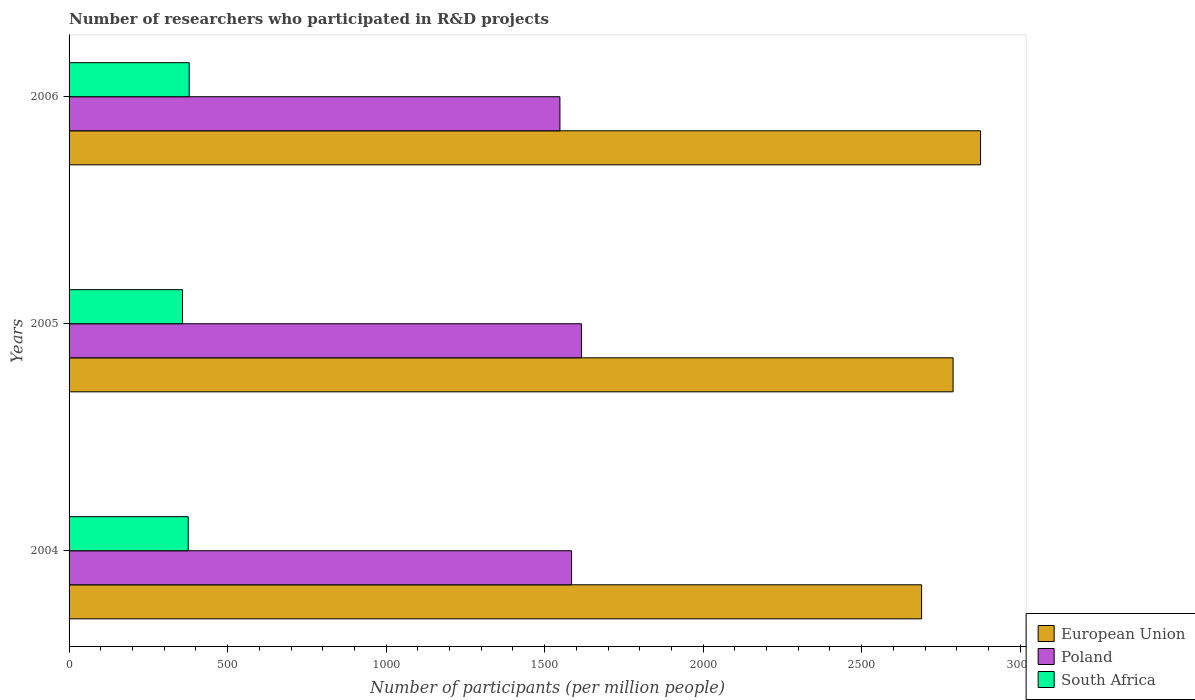How many different coloured bars are there?
Offer a terse response. 3. How many groups of bars are there?
Provide a short and direct response. 3. Are the number of bars on each tick of the Y-axis equal?
Make the answer very short. Yes. In how many cases, is the number of bars for a given year not equal to the number of legend labels?
Make the answer very short. 0. What is the number of researchers who participated in R&D projects in European Union in 2006?
Give a very brief answer. 2874.94. Across all years, what is the maximum number of researchers who participated in R&D projects in South Africa?
Your answer should be compact. 378.82. Across all years, what is the minimum number of researchers who participated in R&D projects in Poland?
Keep it short and to the point. 1548.2. What is the total number of researchers who participated in R&D projects in South Africa in the graph?
Offer a terse response. 1112.49. What is the difference between the number of researchers who participated in R&D projects in Poland in 2004 and that in 2005?
Your answer should be very brief. -31.3. What is the difference between the number of researchers who participated in R&D projects in European Union in 2006 and the number of researchers who participated in R&D projects in South Africa in 2005?
Make the answer very short. 2517.09. What is the average number of researchers who participated in R&D projects in South Africa per year?
Provide a short and direct response. 370.83. In the year 2005, what is the difference between the number of researchers who participated in R&D projects in European Union and number of researchers who participated in R&D projects in South Africa?
Provide a short and direct response. 2430.43. In how many years, is the number of researchers who participated in R&D projects in Poland greater than 1900 ?
Ensure brevity in your answer.  0. What is the ratio of the number of researchers who participated in R&D projects in Poland in 2005 to that in 2006?
Your answer should be compact. 1.04. Is the difference between the number of researchers who participated in R&D projects in European Union in 2005 and 2006 greater than the difference between the number of researchers who participated in R&D projects in South Africa in 2005 and 2006?
Ensure brevity in your answer.  No. What is the difference between the highest and the second highest number of researchers who participated in R&D projects in South Africa?
Your answer should be compact. 3. What is the difference between the highest and the lowest number of researchers who participated in R&D projects in Poland?
Provide a succinct answer. 67.94. What does the 3rd bar from the top in 2005 represents?
Keep it short and to the point. European Union. What does the 2nd bar from the bottom in 2005 represents?
Your response must be concise. Poland. How many bars are there?
Provide a short and direct response. 9. How many years are there in the graph?
Offer a very short reply. 3. Are the values on the major ticks of X-axis written in scientific E-notation?
Ensure brevity in your answer.  No. Where does the legend appear in the graph?
Provide a short and direct response. Bottom right. How are the legend labels stacked?
Provide a short and direct response. Vertical. What is the title of the graph?
Offer a very short reply. Number of researchers who participated in R&D projects. Does "Euro area" appear as one of the legend labels in the graph?
Your answer should be very brief. No. What is the label or title of the X-axis?
Your response must be concise. Number of participants (per million people). What is the label or title of the Y-axis?
Offer a terse response. Years. What is the Number of participants (per million people) of European Union in 2004?
Keep it short and to the point. 2688.97. What is the Number of participants (per million people) in Poland in 2004?
Your response must be concise. 1584.83. What is the Number of participants (per million people) in South Africa in 2004?
Offer a terse response. 375.83. What is the Number of participants (per million people) in European Union in 2005?
Your answer should be compact. 2788.28. What is the Number of participants (per million people) of Poland in 2005?
Offer a terse response. 1616.13. What is the Number of participants (per million people) in South Africa in 2005?
Make the answer very short. 357.85. What is the Number of participants (per million people) of European Union in 2006?
Provide a short and direct response. 2874.94. What is the Number of participants (per million people) in Poland in 2006?
Give a very brief answer. 1548.2. What is the Number of participants (per million people) of South Africa in 2006?
Make the answer very short. 378.82. Across all years, what is the maximum Number of participants (per million people) of European Union?
Give a very brief answer. 2874.94. Across all years, what is the maximum Number of participants (per million people) of Poland?
Provide a short and direct response. 1616.13. Across all years, what is the maximum Number of participants (per million people) in South Africa?
Make the answer very short. 378.82. Across all years, what is the minimum Number of participants (per million people) in European Union?
Offer a terse response. 2688.97. Across all years, what is the minimum Number of participants (per million people) of Poland?
Offer a very short reply. 1548.2. Across all years, what is the minimum Number of participants (per million people) of South Africa?
Keep it short and to the point. 357.85. What is the total Number of participants (per million people) of European Union in the graph?
Your answer should be very brief. 8352.19. What is the total Number of participants (per million people) of Poland in the graph?
Your response must be concise. 4749.16. What is the total Number of participants (per million people) in South Africa in the graph?
Offer a terse response. 1112.49. What is the difference between the Number of participants (per million people) in European Union in 2004 and that in 2005?
Your answer should be very brief. -99.3. What is the difference between the Number of participants (per million people) in Poland in 2004 and that in 2005?
Your answer should be compact. -31.3. What is the difference between the Number of participants (per million people) of South Africa in 2004 and that in 2005?
Give a very brief answer. 17.98. What is the difference between the Number of participants (per million people) in European Union in 2004 and that in 2006?
Your response must be concise. -185.97. What is the difference between the Number of participants (per million people) of Poland in 2004 and that in 2006?
Make the answer very short. 36.64. What is the difference between the Number of participants (per million people) in South Africa in 2004 and that in 2006?
Make the answer very short. -3. What is the difference between the Number of participants (per million people) in European Union in 2005 and that in 2006?
Your answer should be very brief. -86.66. What is the difference between the Number of participants (per million people) of Poland in 2005 and that in 2006?
Keep it short and to the point. 67.94. What is the difference between the Number of participants (per million people) of South Africa in 2005 and that in 2006?
Provide a short and direct response. -20.97. What is the difference between the Number of participants (per million people) of European Union in 2004 and the Number of participants (per million people) of Poland in 2005?
Ensure brevity in your answer.  1072.84. What is the difference between the Number of participants (per million people) of European Union in 2004 and the Number of participants (per million people) of South Africa in 2005?
Offer a very short reply. 2331.13. What is the difference between the Number of participants (per million people) of Poland in 2004 and the Number of participants (per million people) of South Africa in 2005?
Make the answer very short. 1226.98. What is the difference between the Number of participants (per million people) of European Union in 2004 and the Number of participants (per million people) of Poland in 2006?
Ensure brevity in your answer.  1140.78. What is the difference between the Number of participants (per million people) of European Union in 2004 and the Number of participants (per million people) of South Africa in 2006?
Offer a very short reply. 2310.15. What is the difference between the Number of participants (per million people) of Poland in 2004 and the Number of participants (per million people) of South Africa in 2006?
Provide a succinct answer. 1206.01. What is the difference between the Number of participants (per million people) in European Union in 2005 and the Number of participants (per million people) in Poland in 2006?
Provide a succinct answer. 1240.08. What is the difference between the Number of participants (per million people) of European Union in 2005 and the Number of participants (per million people) of South Africa in 2006?
Provide a short and direct response. 2409.45. What is the difference between the Number of participants (per million people) of Poland in 2005 and the Number of participants (per million people) of South Africa in 2006?
Keep it short and to the point. 1237.31. What is the average Number of participants (per million people) of European Union per year?
Give a very brief answer. 2784.06. What is the average Number of participants (per million people) in Poland per year?
Give a very brief answer. 1583.05. What is the average Number of participants (per million people) of South Africa per year?
Provide a succinct answer. 370.83. In the year 2004, what is the difference between the Number of participants (per million people) in European Union and Number of participants (per million people) in Poland?
Provide a succinct answer. 1104.14. In the year 2004, what is the difference between the Number of participants (per million people) in European Union and Number of participants (per million people) in South Africa?
Offer a very short reply. 2313.15. In the year 2004, what is the difference between the Number of participants (per million people) of Poland and Number of participants (per million people) of South Africa?
Offer a very short reply. 1209.01. In the year 2005, what is the difference between the Number of participants (per million people) of European Union and Number of participants (per million people) of Poland?
Keep it short and to the point. 1172.14. In the year 2005, what is the difference between the Number of participants (per million people) of European Union and Number of participants (per million people) of South Africa?
Your answer should be very brief. 2430.43. In the year 2005, what is the difference between the Number of participants (per million people) of Poland and Number of participants (per million people) of South Africa?
Give a very brief answer. 1258.29. In the year 2006, what is the difference between the Number of participants (per million people) of European Union and Number of participants (per million people) of Poland?
Provide a short and direct response. 1326.74. In the year 2006, what is the difference between the Number of participants (per million people) in European Union and Number of participants (per million people) in South Africa?
Provide a short and direct response. 2496.12. In the year 2006, what is the difference between the Number of participants (per million people) in Poland and Number of participants (per million people) in South Africa?
Your answer should be very brief. 1169.38. What is the ratio of the Number of participants (per million people) in European Union in 2004 to that in 2005?
Your answer should be compact. 0.96. What is the ratio of the Number of participants (per million people) in Poland in 2004 to that in 2005?
Your response must be concise. 0.98. What is the ratio of the Number of participants (per million people) of South Africa in 2004 to that in 2005?
Make the answer very short. 1.05. What is the ratio of the Number of participants (per million people) in European Union in 2004 to that in 2006?
Offer a very short reply. 0.94. What is the ratio of the Number of participants (per million people) of Poland in 2004 to that in 2006?
Your answer should be compact. 1.02. What is the ratio of the Number of participants (per million people) in South Africa in 2004 to that in 2006?
Your response must be concise. 0.99. What is the ratio of the Number of participants (per million people) of European Union in 2005 to that in 2006?
Give a very brief answer. 0.97. What is the ratio of the Number of participants (per million people) in Poland in 2005 to that in 2006?
Provide a short and direct response. 1.04. What is the ratio of the Number of participants (per million people) in South Africa in 2005 to that in 2006?
Keep it short and to the point. 0.94. What is the difference between the highest and the second highest Number of participants (per million people) in European Union?
Provide a short and direct response. 86.66. What is the difference between the highest and the second highest Number of participants (per million people) of Poland?
Provide a short and direct response. 31.3. What is the difference between the highest and the second highest Number of participants (per million people) of South Africa?
Keep it short and to the point. 3. What is the difference between the highest and the lowest Number of participants (per million people) in European Union?
Offer a terse response. 185.97. What is the difference between the highest and the lowest Number of participants (per million people) in Poland?
Your answer should be very brief. 67.94. What is the difference between the highest and the lowest Number of participants (per million people) of South Africa?
Make the answer very short. 20.97. 